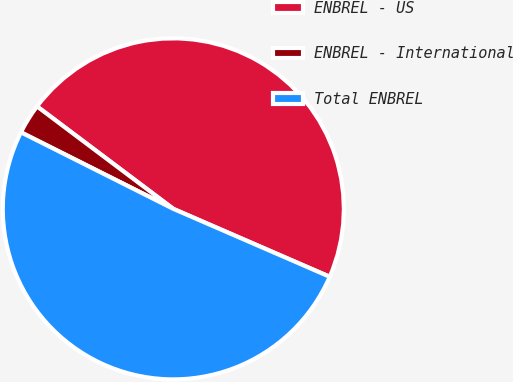Convert chart to OTSL. <chart><loc_0><loc_0><loc_500><loc_500><pie_chart><fcel>ENBREL - US<fcel>ENBREL - International<fcel>Total ENBREL<nl><fcel>46.26%<fcel>2.85%<fcel>50.89%<nl></chart> 